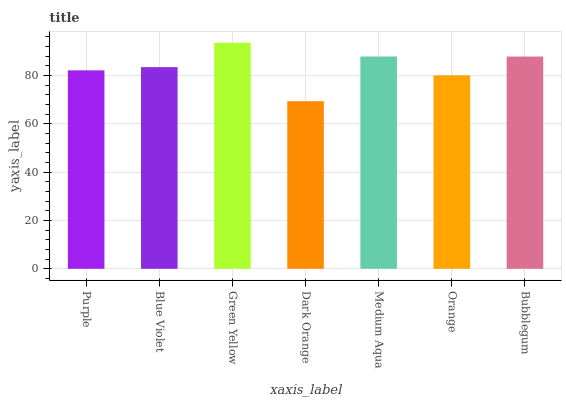Is Dark Orange the minimum?
Answer yes or no. Yes. Is Green Yellow the maximum?
Answer yes or no. Yes. Is Blue Violet the minimum?
Answer yes or no. No. Is Blue Violet the maximum?
Answer yes or no. No. Is Blue Violet greater than Purple?
Answer yes or no. Yes. Is Purple less than Blue Violet?
Answer yes or no. Yes. Is Purple greater than Blue Violet?
Answer yes or no. No. Is Blue Violet less than Purple?
Answer yes or no. No. Is Blue Violet the high median?
Answer yes or no. Yes. Is Blue Violet the low median?
Answer yes or no. Yes. Is Medium Aqua the high median?
Answer yes or no. No. Is Purple the low median?
Answer yes or no. No. 